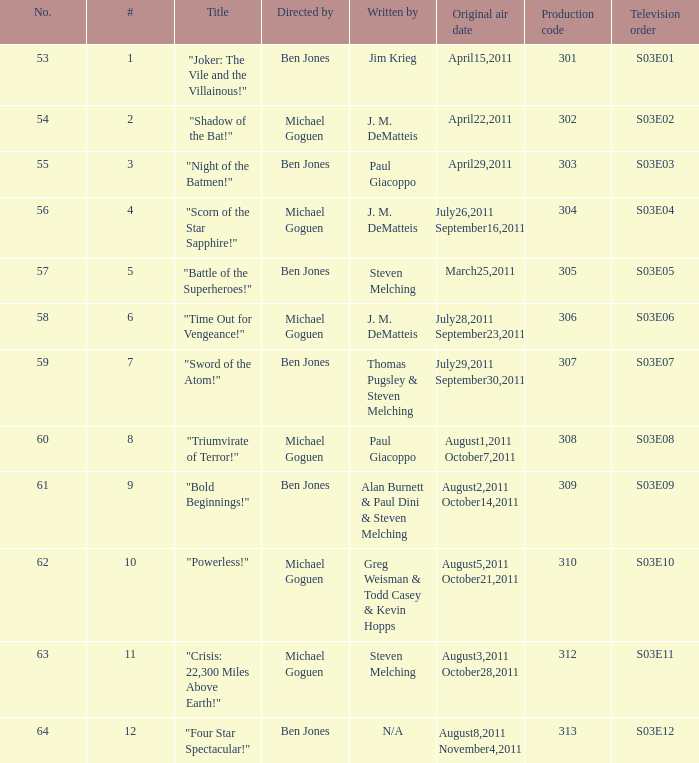Could you help me parse every detail presented in this table? {'header': ['No.', '#', 'Title', 'Directed by', 'Written by', 'Original air date', 'Production code', 'Television order'], 'rows': [['53', '1', '"Joker: The Vile and the Villainous!"', 'Ben Jones', 'Jim Krieg', 'April15,2011', '301', 'S03E01'], ['54', '2', '"Shadow of the Bat!"', 'Michael Goguen', 'J. M. DeMatteis', 'April22,2011', '302', 'S03E02'], ['55', '3', '"Night of the Batmen!"', 'Ben Jones', 'Paul Giacoppo', 'April29,2011', '303', 'S03E03'], ['56', '4', '"Scorn of the Star Sapphire!"', 'Michael Goguen', 'J. M. DeMatteis', 'July26,2011 September16,2011', '304', 'S03E04'], ['57', '5', '"Battle of the Superheroes!"', 'Ben Jones', 'Steven Melching', 'March25,2011', '305', 'S03E05'], ['58', '6', '"Time Out for Vengeance!"', 'Michael Goguen', 'J. M. DeMatteis', 'July28,2011 September23,2011', '306', 'S03E06'], ['59', '7', '"Sword of the Atom!"', 'Ben Jones', 'Thomas Pugsley & Steven Melching', 'July29,2011 September30,2011', '307', 'S03E07'], ['60', '8', '"Triumvirate of Terror!"', 'Michael Goguen', 'Paul Giacoppo', 'August1,2011 October7,2011', '308', 'S03E08'], ['61', '9', '"Bold Beginnings!"', 'Ben Jones', 'Alan Burnett & Paul Dini & Steven Melching', 'August2,2011 October14,2011', '309', 'S03E09'], ['62', '10', '"Powerless!"', 'Michael Goguen', 'Greg Weisman & Todd Casey & Kevin Hopps', 'August5,2011 October21,2011', '310', 'S03E10'], ['63', '11', '"Crisis: 22,300 Miles Above Earth!"', 'Michael Goguen', 'Steven Melching', 'August3,2011 October28,2011', '312', 'S03E11'], ['64', '12', '"Four Star Spectacular!"', 'Ben Jones', 'N/A', 'August8,2011 November4,2011', '313', 'S03E12']]} What is the original air date of the episode directed by ben jones and written by steven melching?  March25,2011. 